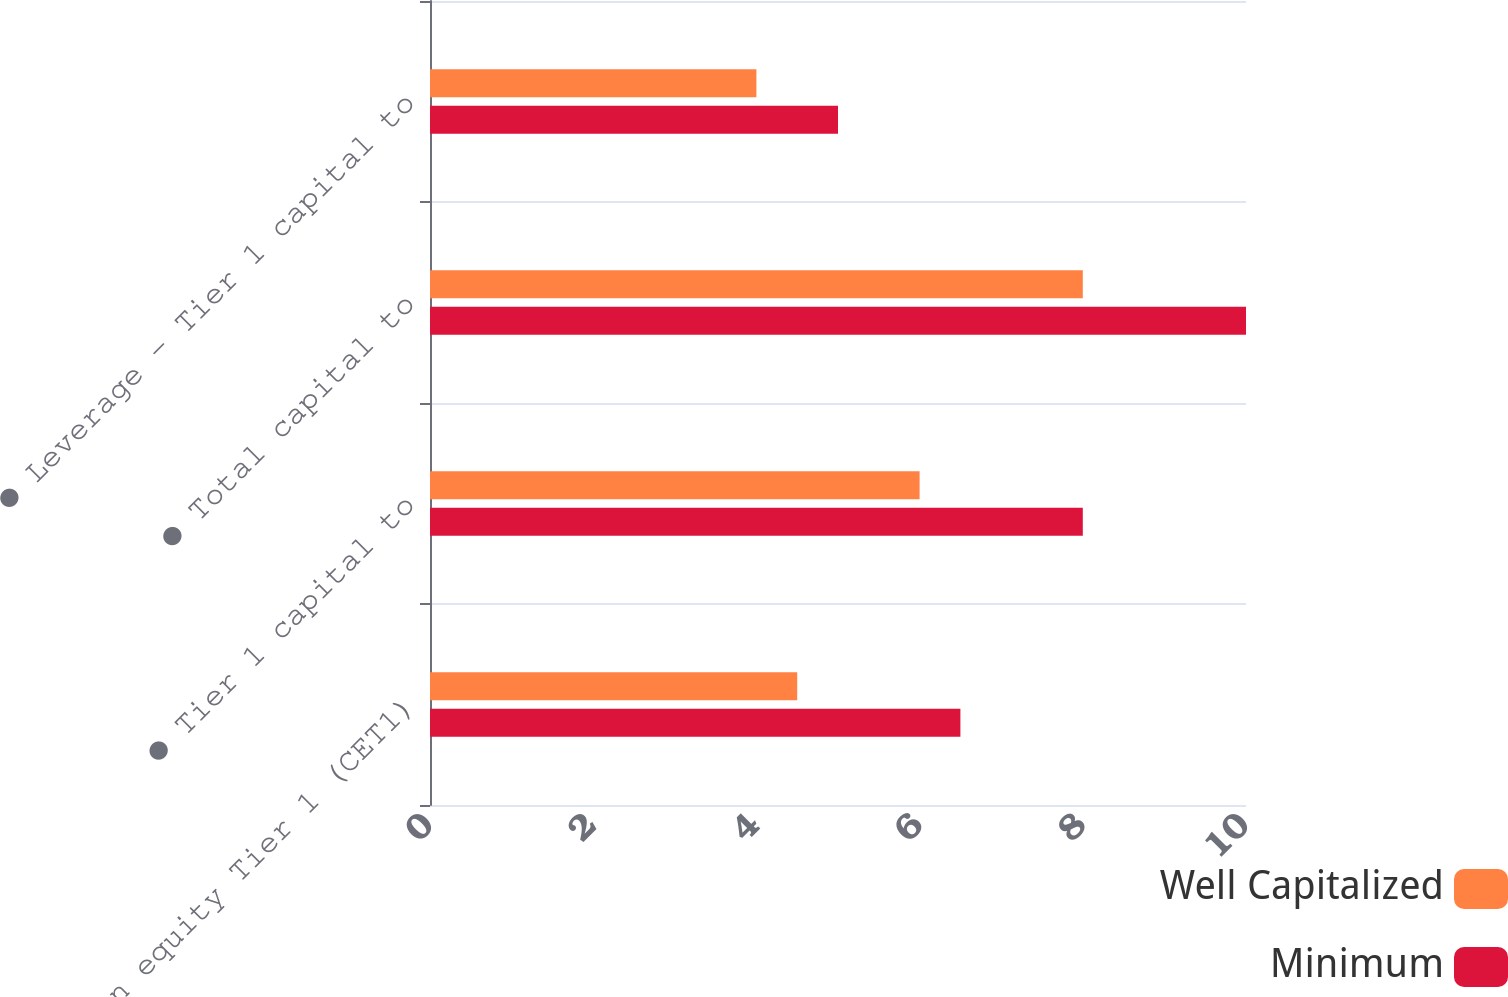<chart> <loc_0><loc_0><loc_500><loc_500><stacked_bar_chart><ecel><fcel>● Common equity Tier 1 (CET1)<fcel>● Tier 1 capital to<fcel>● Total capital to<fcel>● Leverage - Tier 1 capital to<nl><fcel>Well Capitalized<fcel>4.5<fcel>6<fcel>8<fcel>4<nl><fcel>Minimum<fcel>6.5<fcel>8<fcel>10<fcel>5<nl></chart> 